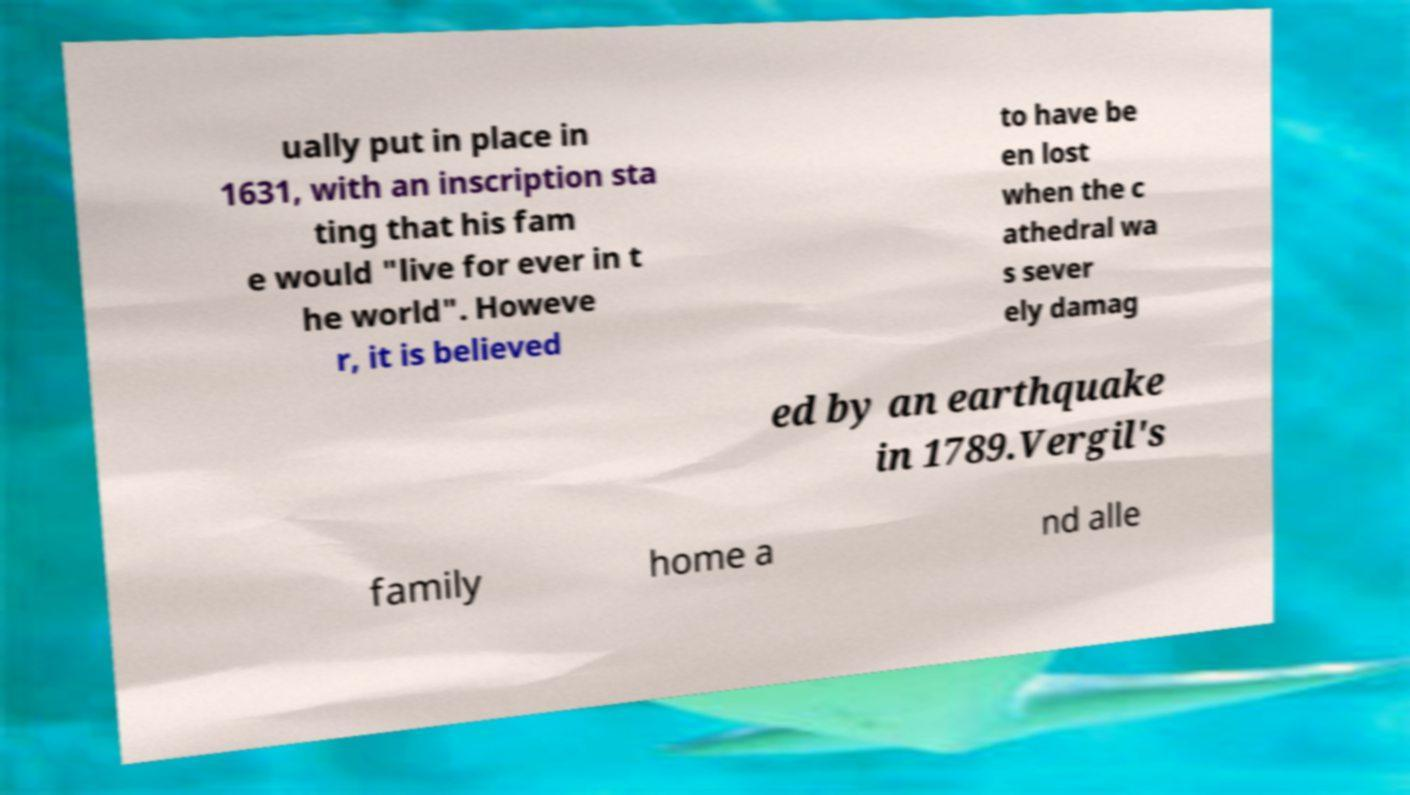Can you read and provide the text displayed in the image?This photo seems to have some interesting text. Can you extract and type it out for me? ually put in place in 1631, with an inscription sta ting that his fam e would "live for ever in t he world". Howeve r, it is believed to have be en lost when the c athedral wa s sever ely damag ed by an earthquake in 1789.Vergil's family home a nd alle 